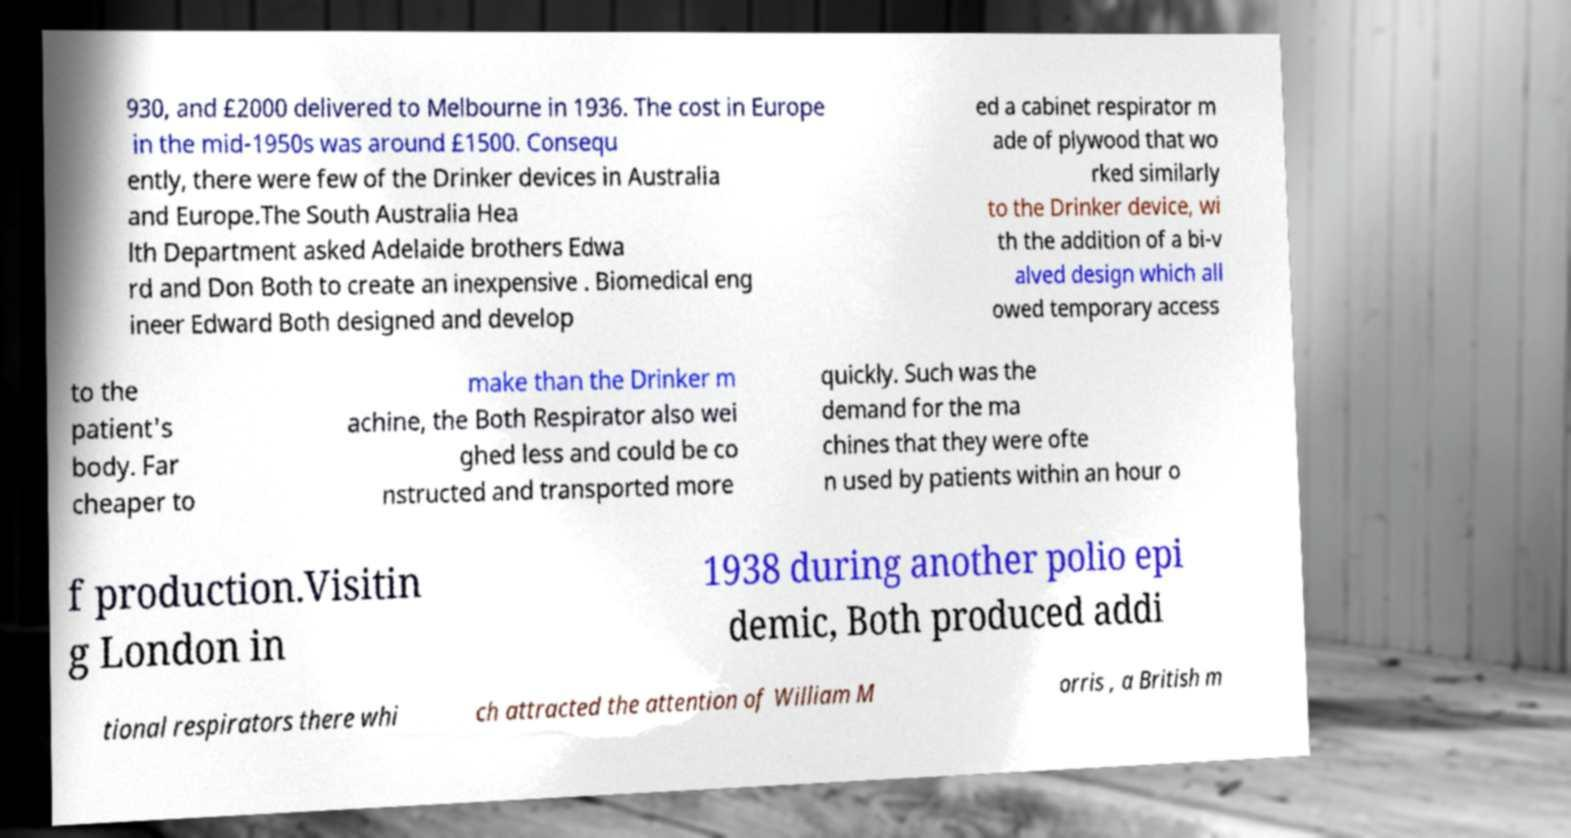Could you extract and type out the text from this image? 930, and £2000 delivered to Melbourne in 1936. The cost in Europe in the mid-1950s was around £1500. Consequ ently, there were few of the Drinker devices in Australia and Europe.The South Australia Hea lth Department asked Adelaide brothers Edwa rd and Don Both to create an inexpensive . Biomedical eng ineer Edward Both designed and develop ed a cabinet respirator m ade of plywood that wo rked similarly to the Drinker device, wi th the addition of a bi-v alved design which all owed temporary access to the patient's body. Far cheaper to make than the Drinker m achine, the Both Respirator also wei ghed less and could be co nstructed and transported more quickly. Such was the demand for the ma chines that they were ofte n used by patients within an hour o f production.Visitin g London in 1938 during another polio epi demic, Both produced addi tional respirators there whi ch attracted the attention of William M orris , a British m 